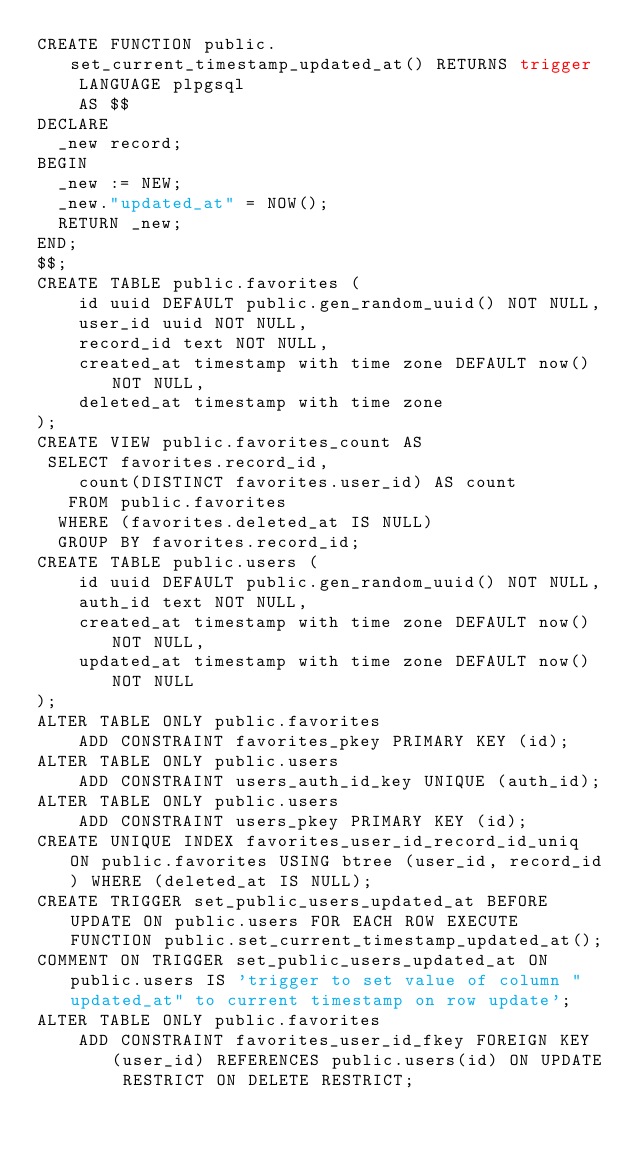<code> <loc_0><loc_0><loc_500><loc_500><_SQL_>CREATE FUNCTION public.set_current_timestamp_updated_at() RETURNS trigger
    LANGUAGE plpgsql
    AS $$
DECLARE
  _new record;
BEGIN
  _new := NEW;
  _new."updated_at" = NOW();
  RETURN _new;
END;
$$;
CREATE TABLE public.favorites (
    id uuid DEFAULT public.gen_random_uuid() NOT NULL,
    user_id uuid NOT NULL,
    record_id text NOT NULL,
    created_at timestamp with time zone DEFAULT now() NOT NULL,
    deleted_at timestamp with time zone
);
CREATE VIEW public.favorites_count AS
 SELECT favorites.record_id,
    count(DISTINCT favorites.user_id) AS count
   FROM public.favorites
  WHERE (favorites.deleted_at IS NULL)
  GROUP BY favorites.record_id;
CREATE TABLE public.users (
    id uuid DEFAULT public.gen_random_uuid() NOT NULL,
    auth_id text NOT NULL,
    created_at timestamp with time zone DEFAULT now() NOT NULL,
    updated_at timestamp with time zone DEFAULT now() NOT NULL
);
ALTER TABLE ONLY public.favorites
    ADD CONSTRAINT favorites_pkey PRIMARY KEY (id);
ALTER TABLE ONLY public.users
    ADD CONSTRAINT users_auth_id_key UNIQUE (auth_id);
ALTER TABLE ONLY public.users
    ADD CONSTRAINT users_pkey PRIMARY KEY (id);
CREATE UNIQUE INDEX favorites_user_id_record_id_uniq ON public.favorites USING btree (user_id, record_id) WHERE (deleted_at IS NULL);
CREATE TRIGGER set_public_users_updated_at BEFORE UPDATE ON public.users FOR EACH ROW EXECUTE FUNCTION public.set_current_timestamp_updated_at();
COMMENT ON TRIGGER set_public_users_updated_at ON public.users IS 'trigger to set value of column "updated_at" to current timestamp on row update';
ALTER TABLE ONLY public.favorites
    ADD CONSTRAINT favorites_user_id_fkey FOREIGN KEY (user_id) REFERENCES public.users(id) ON UPDATE RESTRICT ON DELETE RESTRICT;
</code> 